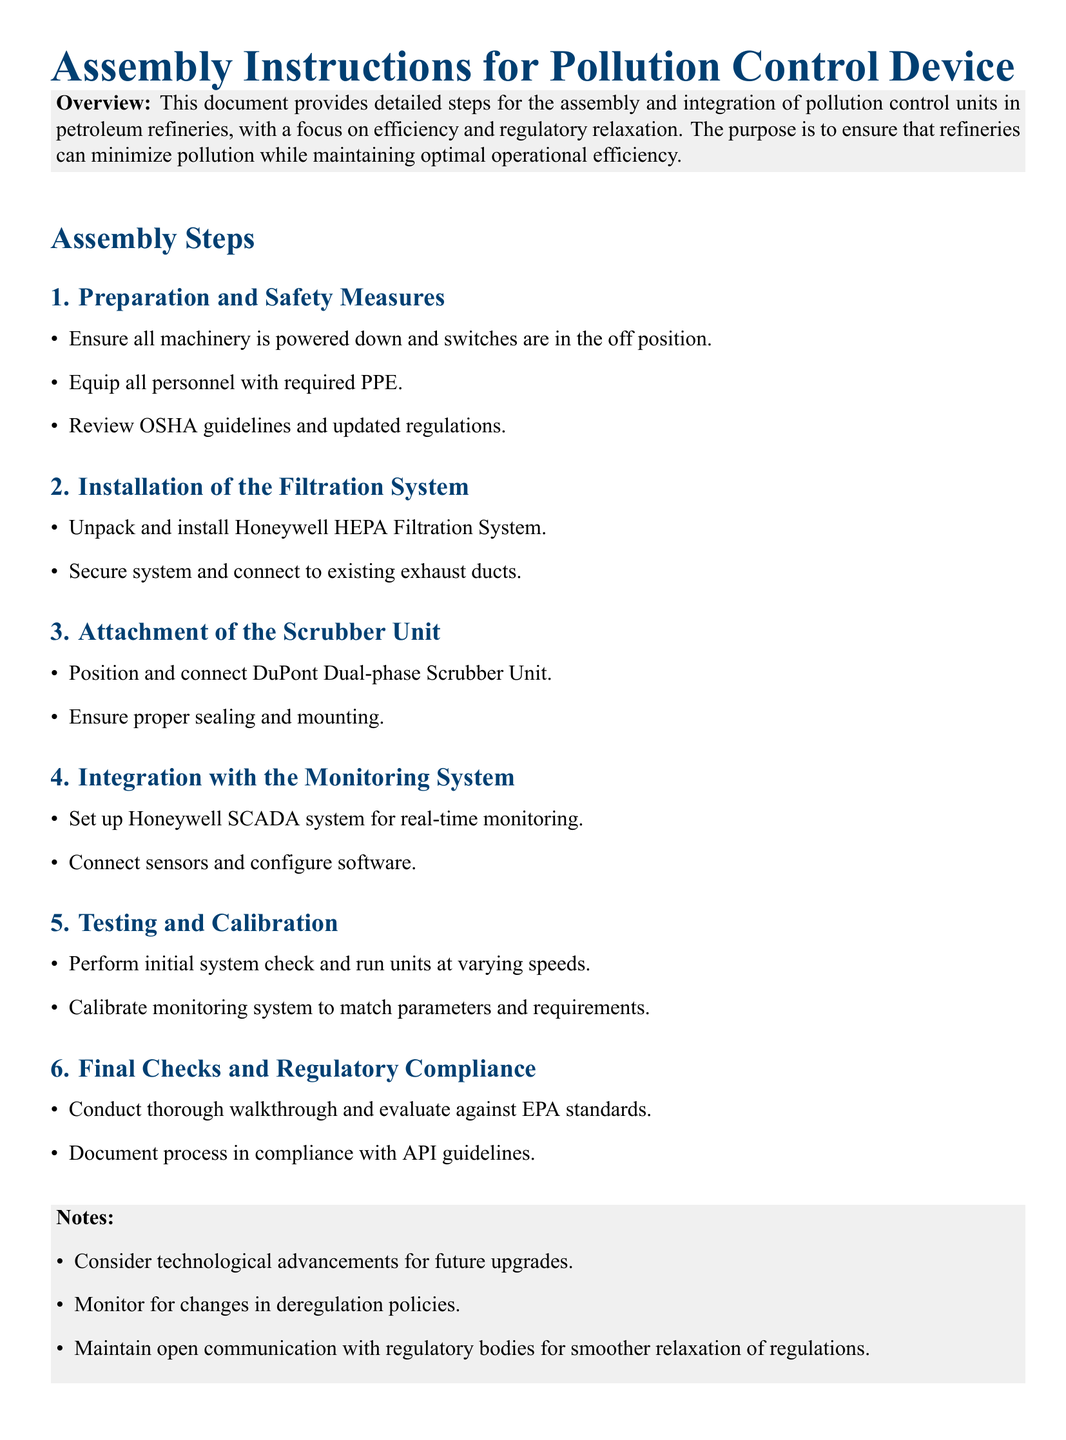What is the purpose of the assembly instructions? The document states the purpose is to ensure that refineries can minimize pollution while maintaining optimal operational efficiency.
Answer: Minimize pollution What type of filtration system is used? The document specifies the installation of the Honeywell HEPA Filtration System.
Answer: Honeywell HEPA Filtration System Which unit needs to be connected after the filtration system? The assembly instructions indicate that the DuPont Dual-phase Scrubber Unit should be attached next.
Answer: DuPont Dual-phase Scrubber Unit What is the final step in the assembly instructions? The document outlines that the final checks and regulatory compliance is the last step.
Answer: Final checks and regulatory compliance Which system is set up for real-time monitoring? The document mentions setting up the Honeywell SCADA system for real-time monitoring.
Answer: Honeywell SCADA system What should personnel wear during preparation? The instructions state that personnel should be equipped with required PPE.
Answer: Required PPE What should be reviewed prior to assembly? The assembly instructions advise reviewing OSHA guidelines and updated regulations.
Answer: OSHA guidelines What are the notes regarding technological advancements? The notes suggest considering technological advancements for future upgrades.
Answer: Future upgrades What organization’s standards should compliance be evaluated against? The document states that compliance should be evaluated against EPA standards.
Answer: EPA standards 